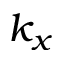Convert formula to latex. <formula><loc_0><loc_0><loc_500><loc_500>k _ { x }</formula> 